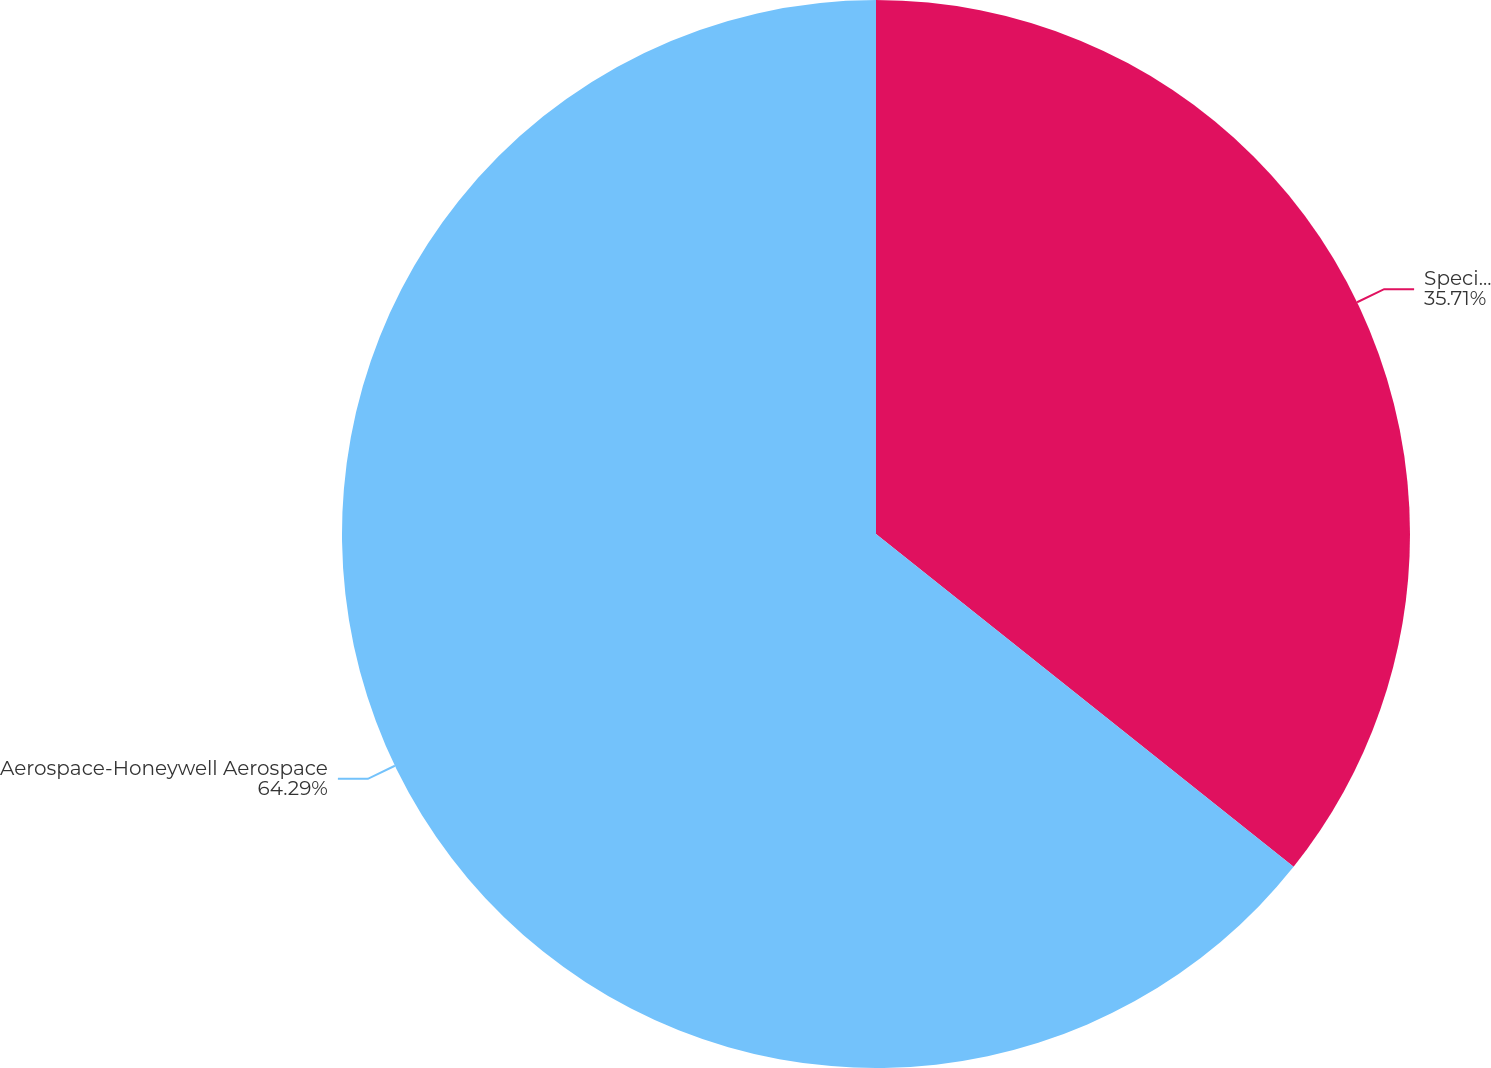<chart> <loc_0><loc_0><loc_500><loc_500><pie_chart><fcel>Specialty<fcel>Aerospace-Honeywell Aerospace<nl><fcel>35.71%<fcel>64.29%<nl></chart> 